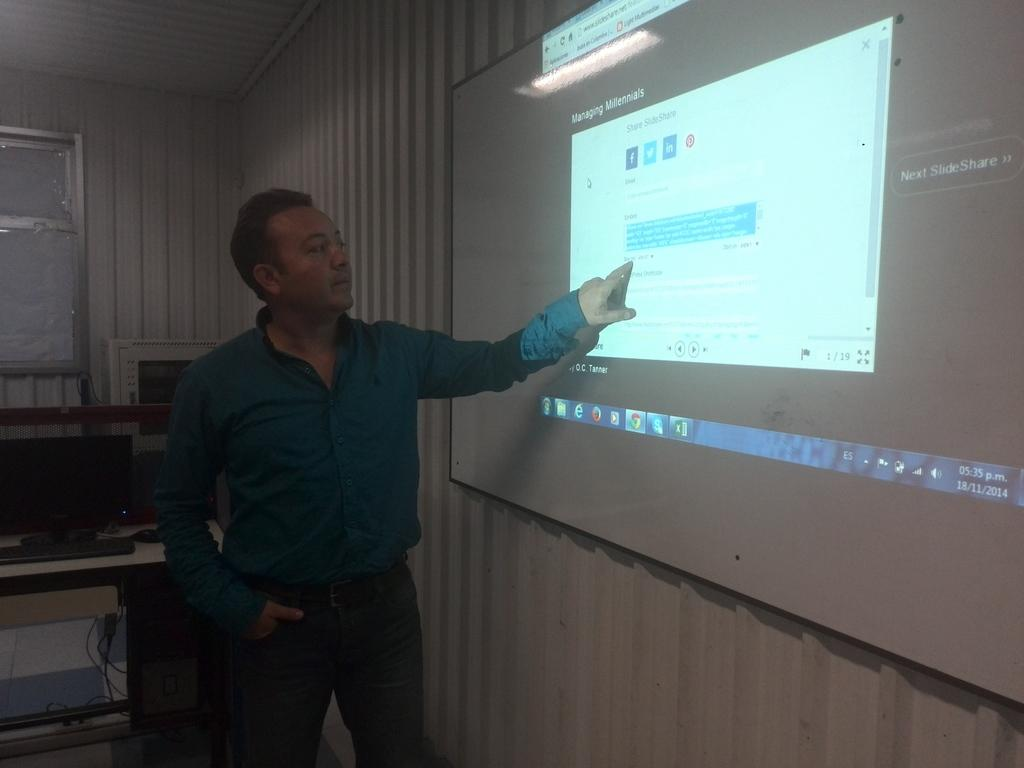<image>
Render a clear and concise summary of the photo. A man shows a presentation on Managing Milennials. 